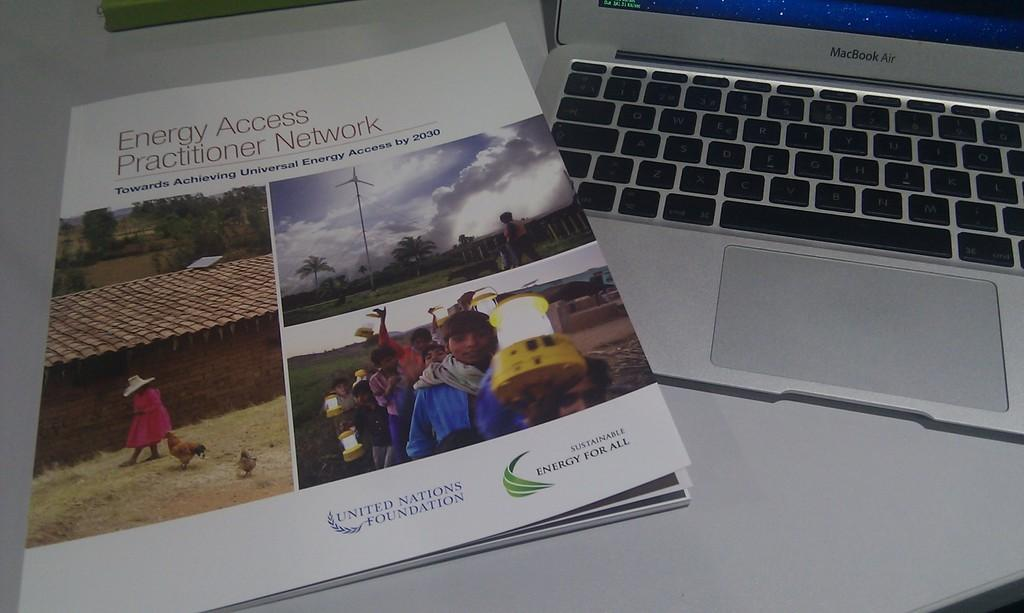<image>
Give a short and clear explanation of the subsequent image. A pamphlet made by the United Nations Foundation is next to a Macbook Air. 